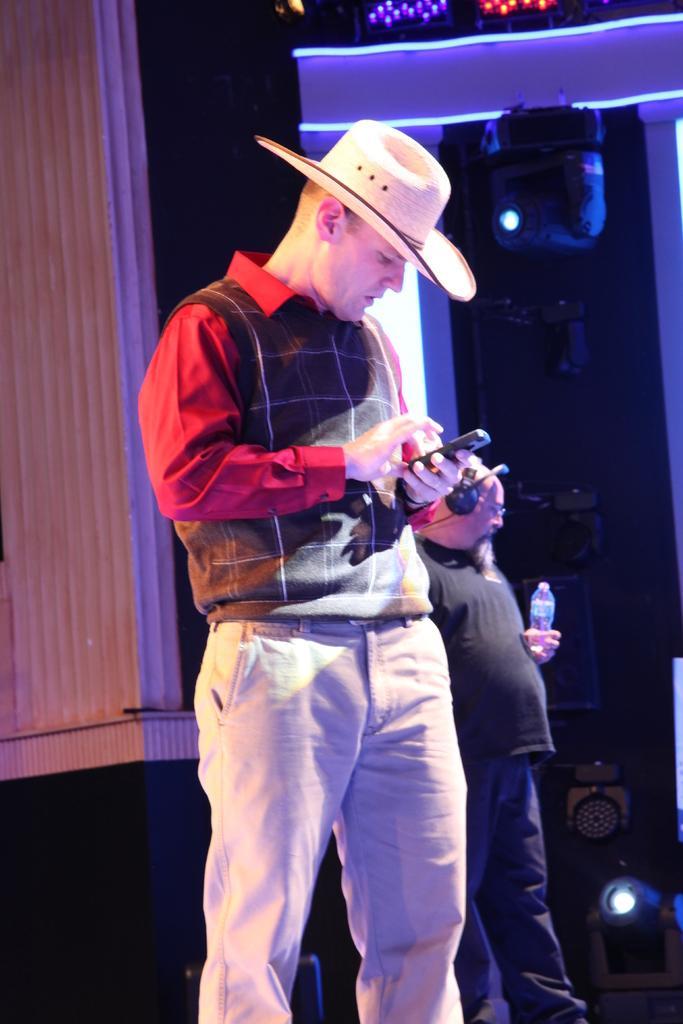Could you give a brief overview of what you see in this image? In this image I can see two people with different color dresses and one person with the cap. I can see one person is holding the mobile and another person is holding the bottle. In the background I can see the lights and the sound boxes. 